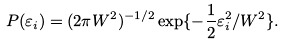Convert formula to latex. <formula><loc_0><loc_0><loc_500><loc_500>P ( \varepsilon _ { i } ) = ( 2 \pi W ^ { 2 } ) ^ { - 1 / 2 } \exp \{ - \frac { 1 } { 2 } \varepsilon _ { i } ^ { 2 } / W ^ { 2 } \} .</formula> 